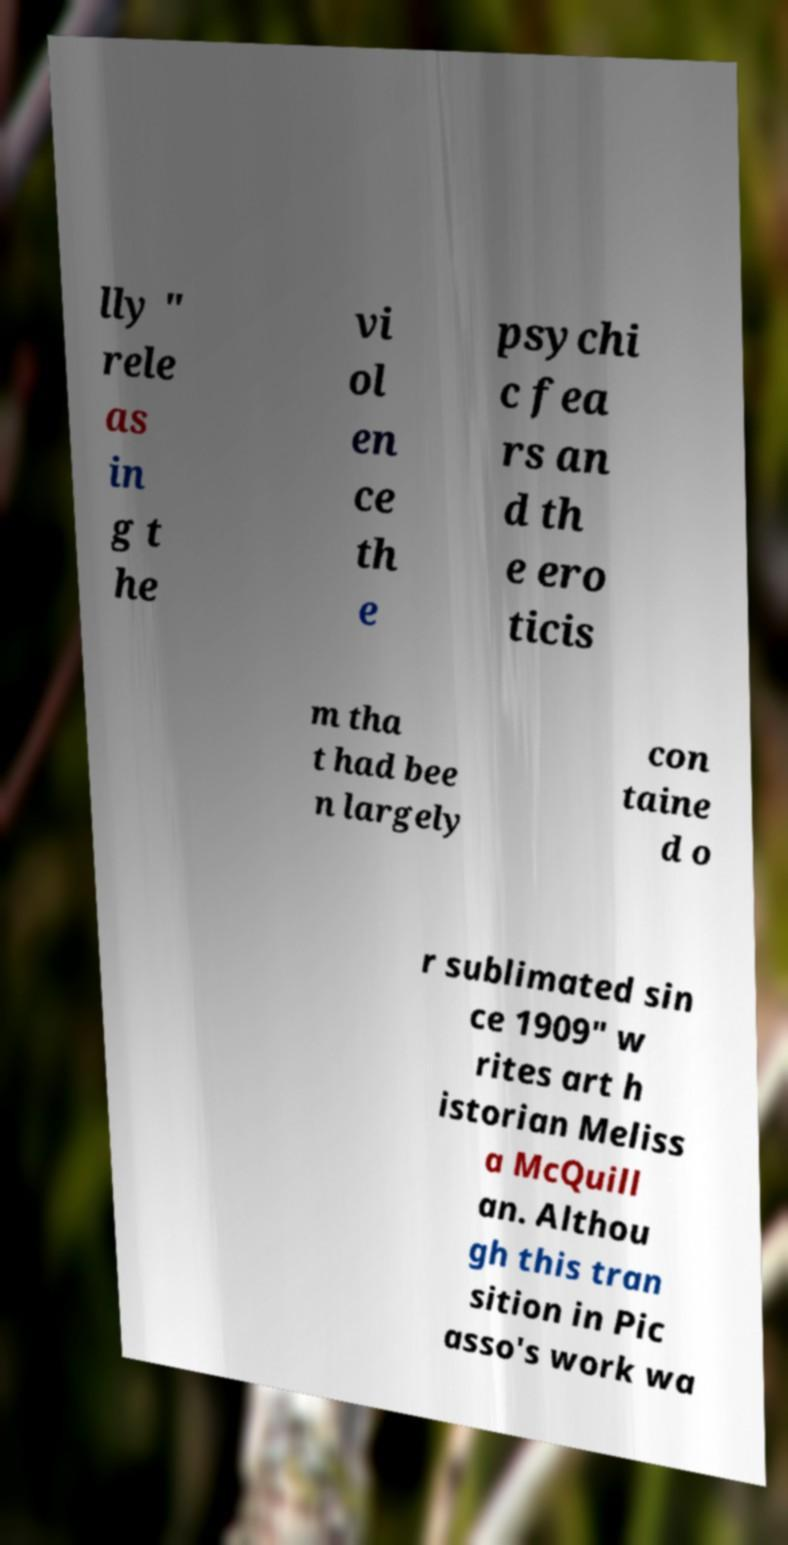Could you extract and type out the text from this image? lly " rele as in g t he vi ol en ce th e psychi c fea rs an d th e ero ticis m tha t had bee n largely con taine d o r sublimated sin ce 1909" w rites art h istorian Meliss a McQuill an. Althou gh this tran sition in Pic asso's work wa 